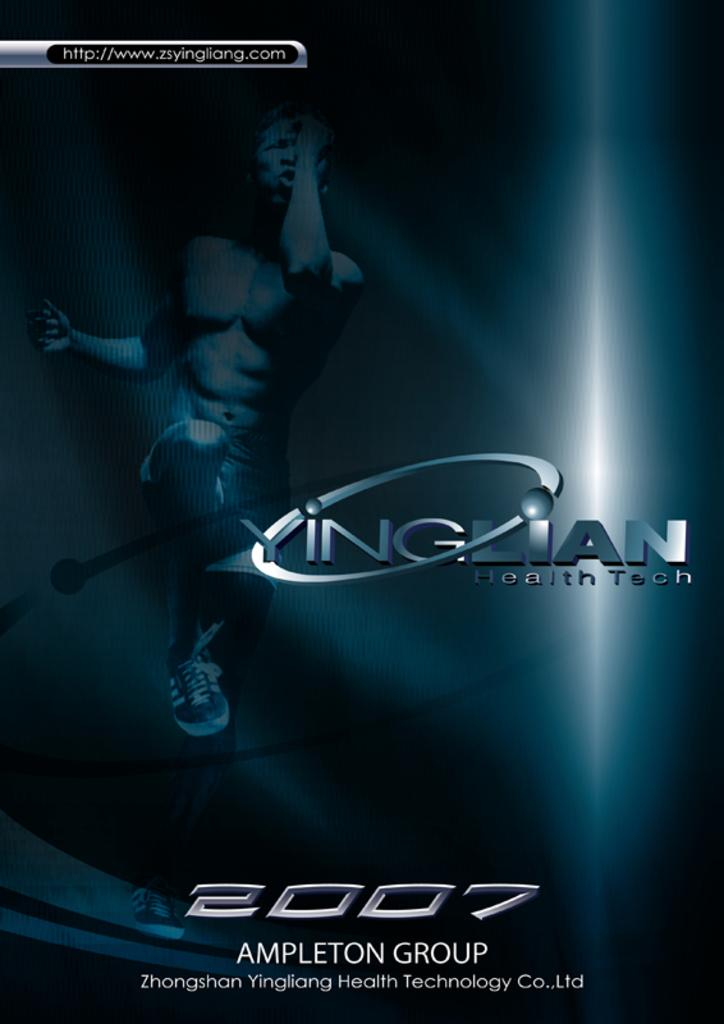<image>
Render a clear and concise summary of the photo. An advertisement for YingLian has the year 2007 on the bottom of it. 